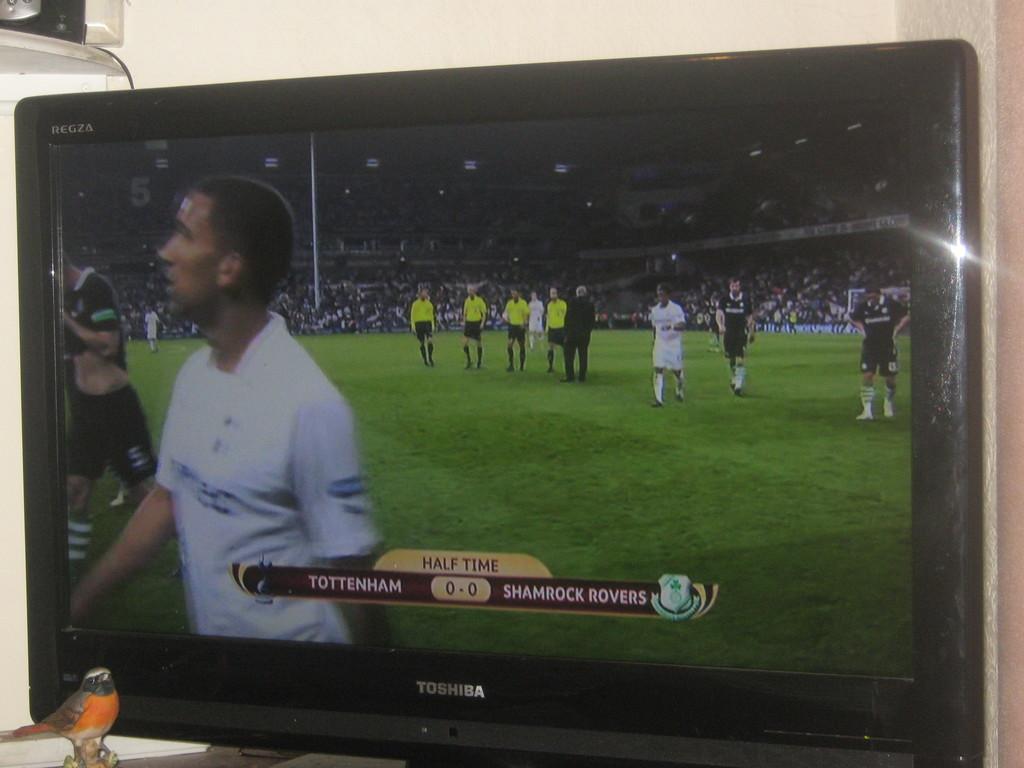What time is it in the soccer game?
Your answer should be compact. Half time. Who is playing in the game?
Give a very brief answer. Tottenham and shamrock rovers. 